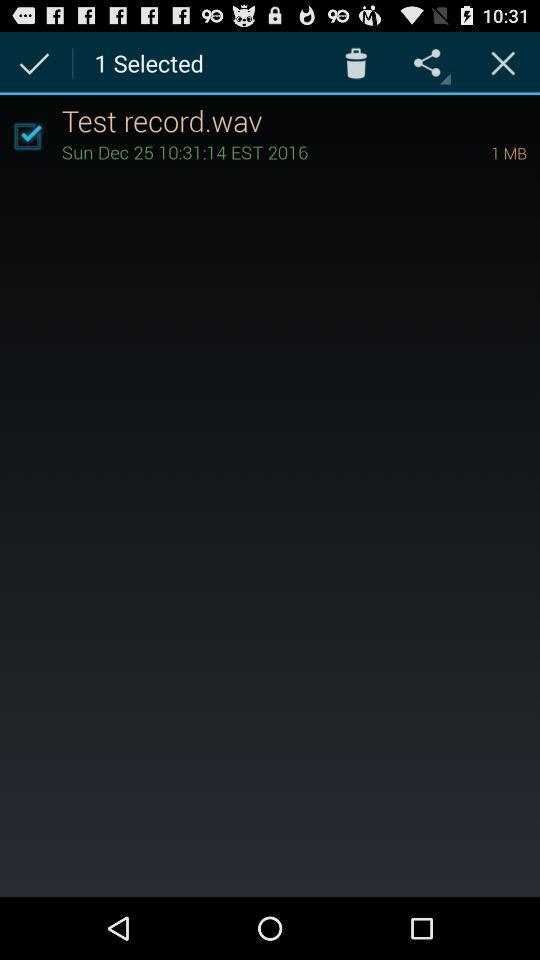How many files are selected?
Answer the question using a single word or phrase. 1 